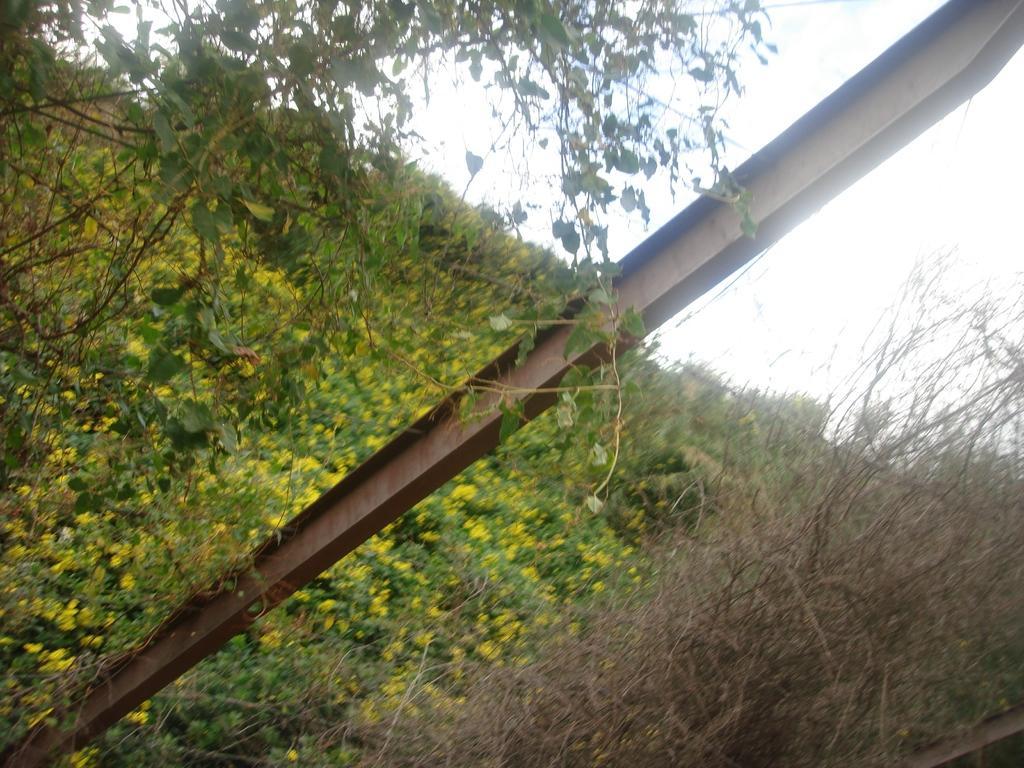How would you summarize this image in a sentence or two? In this image I can see a pole, few wires, number of flowers and number of plants in the front. In the background I can see the sky and I can also see this image is little bit blurry. 